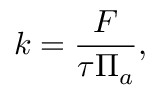Convert formula to latex. <formula><loc_0><loc_0><loc_500><loc_500>k = \frac { F } { \tau \Pi _ { a } } ,</formula> 